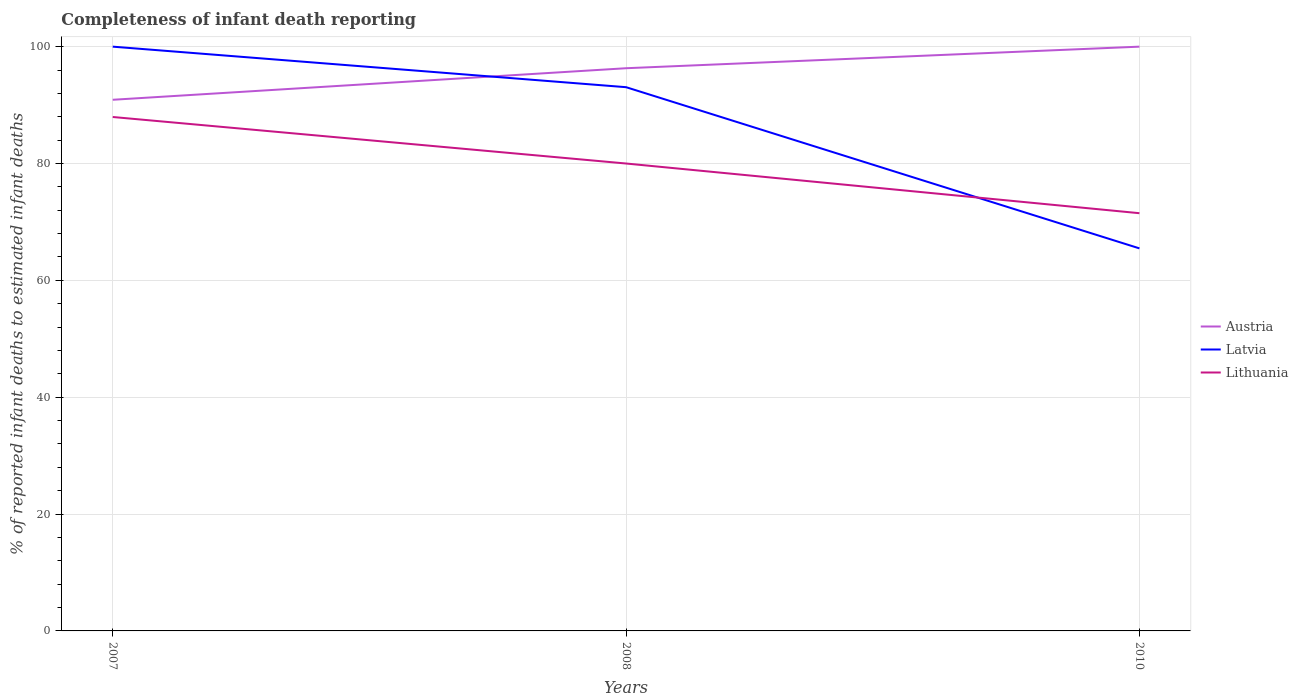Does the line corresponding to Lithuania intersect with the line corresponding to Austria?
Provide a short and direct response. No. Is the number of lines equal to the number of legend labels?
Your answer should be compact. Yes. Across all years, what is the maximum percentage of infant deaths reported in Latvia?
Your answer should be compact. 65.48. In which year was the percentage of infant deaths reported in Austria maximum?
Provide a succinct answer. 2007. What is the total percentage of infant deaths reported in Latvia in the graph?
Keep it short and to the point. 6.94. What is the difference between the highest and the second highest percentage of infant deaths reported in Lithuania?
Offer a very short reply. 16.47. What is the difference between the highest and the lowest percentage of infant deaths reported in Latvia?
Keep it short and to the point. 2. How many lines are there?
Make the answer very short. 3. How many years are there in the graph?
Your answer should be very brief. 3. Does the graph contain any zero values?
Make the answer very short. No. Does the graph contain grids?
Offer a terse response. Yes. Where does the legend appear in the graph?
Offer a very short reply. Center right. What is the title of the graph?
Ensure brevity in your answer.  Completeness of infant death reporting. Does "Pakistan" appear as one of the legend labels in the graph?
Your response must be concise. No. What is the label or title of the X-axis?
Your response must be concise. Years. What is the label or title of the Y-axis?
Make the answer very short. % of reported infant deaths to estimated infant deaths. What is the % of reported infant deaths to estimated infant deaths in Austria in 2007?
Make the answer very short. 90.91. What is the % of reported infant deaths to estimated infant deaths of Lithuania in 2007?
Offer a very short reply. 87.96. What is the % of reported infant deaths to estimated infant deaths in Austria in 2008?
Offer a terse response. 96.31. What is the % of reported infant deaths to estimated infant deaths of Latvia in 2008?
Give a very brief answer. 93.06. What is the % of reported infant deaths to estimated infant deaths of Austria in 2010?
Provide a short and direct response. 100. What is the % of reported infant deaths to estimated infant deaths of Latvia in 2010?
Your answer should be compact. 65.48. What is the % of reported infant deaths to estimated infant deaths in Lithuania in 2010?
Make the answer very short. 71.5. Across all years, what is the maximum % of reported infant deaths to estimated infant deaths of Latvia?
Offer a terse response. 100. Across all years, what is the maximum % of reported infant deaths to estimated infant deaths in Lithuania?
Offer a terse response. 87.96. Across all years, what is the minimum % of reported infant deaths to estimated infant deaths in Austria?
Keep it short and to the point. 90.91. Across all years, what is the minimum % of reported infant deaths to estimated infant deaths in Latvia?
Make the answer very short. 65.48. Across all years, what is the minimum % of reported infant deaths to estimated infant deaths of Lithuania?
Provide a succinct answer. 71.5. What is the total % of reported infant deaths to estimated infant deaths in Austria in the graph?
Give a very brief answer. 287.22. What is the total % of reported infant deaths to estimated infant deaths of Latvia in the graph?
Keep it short and to the point. 258.54. What is the total % of reported infant deaths to estimated infant deaths of Lithuania in the graph?
Offer a terse response. 239.46. What is the difference between the % of reported infant deaths to estimated infant deaths in Austria in 2007 and that in 2008?
Give a very brief answer. -5.4. What is the difference between the % of reported infant deaths to estimated infant deaths of Latvia in 2007 and that in 2008?
Offer a terse response. 6.94. What is the difference between the % of reported infant deaths to estimated infant deaths of Lithuania in 2007 and that in 2008?
Offer a very short reply. 7.96. What is the difference between the % of reported infant deaths to estimated infant deaths in Austria in 2007 and that in 2010?
Provide a succinct answer. -9.09. What is the difference between the % of reported infant deaths to estimated infant deaths in Latvia in 2007 and that in 2010?
Ensure brevity in your answer.  34.52. What is the difference between the % of reported infant deaths to estimated infant deaths of Lithuania in 2007 and that in 2010?
Your answer should be compact. 16.47. What is the difference between the % of reported infant deaths to estimated infant deaths in Austria in 2008 and that in 2010?
Give a very brief answer. -3.69. What is the difference between the % of reported infant deaths to estimated infant deaths of Latvia in 2008 and that in 2010?
Make the answer very short. 27.59. What is the difference between the % of reported infant deaths to estimated infant deaths in Lithuania in 2008 and that in 2010?
Ensure brevity in your answer.  8.5. What is the difference between the % of reported infant deaths to estimated infant deaths in Austria in 2007 and the % of reported infant deaths to estimated infant deaths in Latvia in 2008?
Make the answer very short. -2.15. What is the difference between the % of reported infant deaths to estimated infant deaths in Austria in 2007 and the % of reported infant deaths to estimated infant deaths in Lithuania in 2008?
Offer a terse response. 10.91. What is the difference between the % of reported infant deaths to estimated infant deaths in Latvia in 2007 and the % of reported infant deaths to estimated infant deaths in Lithuania in 2008?
Provide a short and direct response. 20. What is the difference between the % of reported infant deaths to estimated infant deaths of Austria in 2007 and the % of reported infant deaths to estimated infant deaths of Latvia in 2010?
Provide a succinct answer. 25.43. What is the difference between the % of reported infant deaths to estimated infant deaths of Austria in 2007 and the % of reported infant deaths to estimated infant deaths of Lithuania in 2010?
Your answer should be compact. 19.41. What is the difference between the % of reported infant deaths to estimated infant deaths of Latvia in 2007 and the % of reported infant deaths to estimated infant deaths of Lithuania in 2010?
Provide a short and direct response. 28.5. What is the difference between the % of reported infant deaths to estimated infant deaths in Austria in 2008 and the % of reported infant deaths to estimated infant deaths in Latvia in 2010?
Provide a succinct answer. 30.83. What is the difference between the % of reported infant deaths to estimated infant deaths of Austria in 2008 and the % of reported infant deaths to estimated infant deaths of Lithuania in 2010?
Provide a succinct answer. 24.81. What is the difference between the % of reported infant deaths to estimated infant deaths in Latvia in 2008 and the % of reported infant deaths to estimated infant deaths in Lithuania in 2010?
Your answer should be very brief. 21.57. What is the average % of reported infant deaths to estimated infant deaths of Austria per year?
Provide a short and direct response. 95.74. What is the average % of reported infant deaths to estimated infant deaths in Latvia per year?
Provide a succinct answer. 86.18. What is the average % of reported infant deaths to estimated infant deaths of Lithuania per year?
Offer a terse response. 79.82. In the year 2007, what is the difference between the % of reported infant deaths to estimated infant deaths of Austria and % of reported infant deaths to estimated infant deaths of Latvia?
Give a very brief answer. -9.09. In the year 2007, what is the difference between the % of reported infant deaths to estimated infant deaths in Austria and % of reported infant deaths to estimated infant deaths in Lithuania?
Your response must be concise. 2.95. In the year 2007, what is the difference between the % of reported infant deaths to estimated infant deaths in Latvia and % of reported infant deaths to estimated infant deaths in Lithuania?
Ensure brevity in your answer.  12.04. In the year 2008, what is the difference between the % of reported infant deaths to estimated infant deaths in Austria and % of reported infant deaths to estimated infant deaths in Latvia?
Offer a terse response. 3.25. In the year 2008, what is the difference between the % of reported infant deaths to estimated infant deaths of Austria and % of reported infant deaths to estimated infant deaths of Lithuania?
Provide a succinct answer. 16.31. In the year 2008, what is the difference between the % of reported infant deaths to estimated infant deaths of Latvia and % of reported infant deaths to estimated infant deaths of Lithuania?
Provide a succinct answer. 13.06. In the year 2010, what is the difference between the % of reported infant deaths to estimated infant deaths of Austria and % of reported infant deaths to estimated infant deaths of Latvia?
Ensure brevity in your answer.  34.52. In the year 2010, what is the difference between the % of reported infant deaths to estimated infant deaths of Austria and % of reported infant deaths to estimated infant deaths of Lithuania?
Make the answer very short. 28.5. In the year 2010, what is the difference between the % of reported infant deaths to estimated infant deaths of Latvia and % of reported infant deaths to estimated infant deaths of Lithuania?
Make the answer very short. -6.02. What is the ratio of the % of reported infant deaths to estimated infant deaths of Austria in 2007 to that in 2008?
Offer a terse response. 0.94. What is the ratio of the % of reported infant deaths to estimated infant deaths in Latvia in 2007 to that in 2008?
Your answer should be compact. 1.07. What is the ratio of the % of reported infant deaths to estimated infant deaths of Lithuania in 2007 to that in 2008?
Make the answer very short. 1.1. What is the ratio of the % of reported infant deaths to estimated infant deaths of Latvia in 2007 to that in 2010?
Provide a short and direct response. 1.53. What is the ratio of the % of reported infant deaths to estimated infant deaths of Lithuania in 2007 to that in 2010?
Offer a terse response. 1.23. What is the ratio of the % of reported infant deaths to estimated infant deaths in Austria in 2008 to that in 2010?
Provide a short and direct response. 0.96. What is the ratio of the % of reported infant deaths to estimated infant deaths in Latvia in 2008 to that in 2010?
Ensure brevity in your answer.  1.42. What is the ratio of the % of reported infant deaths to estimated infant deaths in Lithuania in 2008 to that in 2010?
Provide a succinct answer. 1.12. What is the difference between the highest and the second highest % of reported infant deaths to estimated infant deaths of Austria?
Provide a succinct answer. 3.69. What is the difference between the highest and the second highest % of reported infant deaths to estimated infant deaths in Latvia?
Offer a terse response. 6.94. What is the difference between the highest and the second highest % of reported infant deaths to estimated infant deaths of Lithuania?
Offer a very short reply. 7.96. What is the difference between the highest and the lowest % of reported infant deaths to estimated infant deaths of Austria?
Your answer should be compact. 9.09. What is the difference between the highest and the lowest % of reported infant deaths to estimated infant deaths of Latvia?
Make the answer very short. 34.52. What is the difference between the highest and the lowest % of reported infant deaths to estimated infant deaths in Lithuania?
Provide a short and direct response. 16.47. 